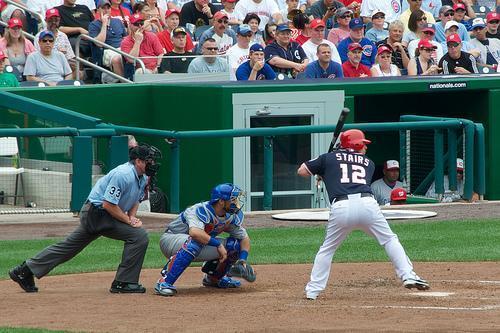How many people are on the baseball field?
Give a very brief answer. 3. 